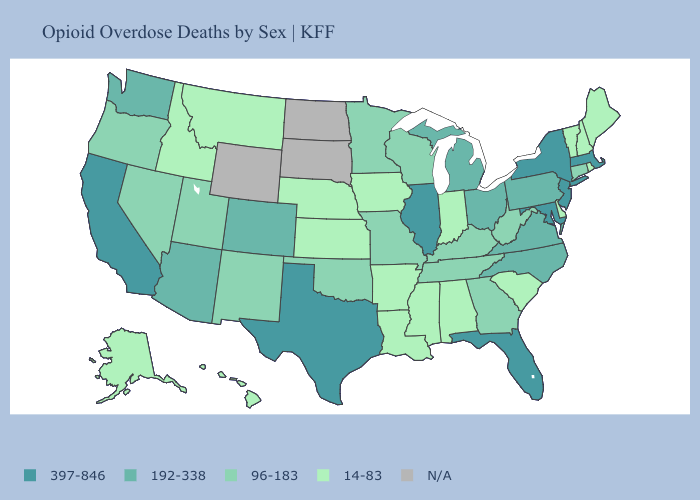Does the first symbol in the legend represent the smallest category?
Concise answer only. No. Among the states that border Florida , does Georgia have the lowest value?
Give a very brief answer. No. What is the highest value in states that border New Hampshire?
Keep it brief. 397-846. What is the value of New Jersey?
Keep it brief. 397-846. Does Indiana have the lowest value in the USA?
Short answer required. Yes. Among the states that border Mississippi , which have the lowest value?
Be succinct. Alabama, Arkansas, Louisiana. What is the value of Utah?
Short answer required. 96-183. Is the legend a continuous bar?
Concise answer only. No. Does Texas have the highest value in the USA?
Give a very brief answer. Yes. What is the value of Arizona?
Keep it brief. 192-338. What is the highest value in the USA?
Be succinct. 397-846. Among the states that border Kansas , which have the lowest value?
Answer briefly. Nebraska. Which states have the lowest value in the South?
Be succinct. Alabama, Arkansas, Delaware, Louisiana, Mississippi, South Carolina. 